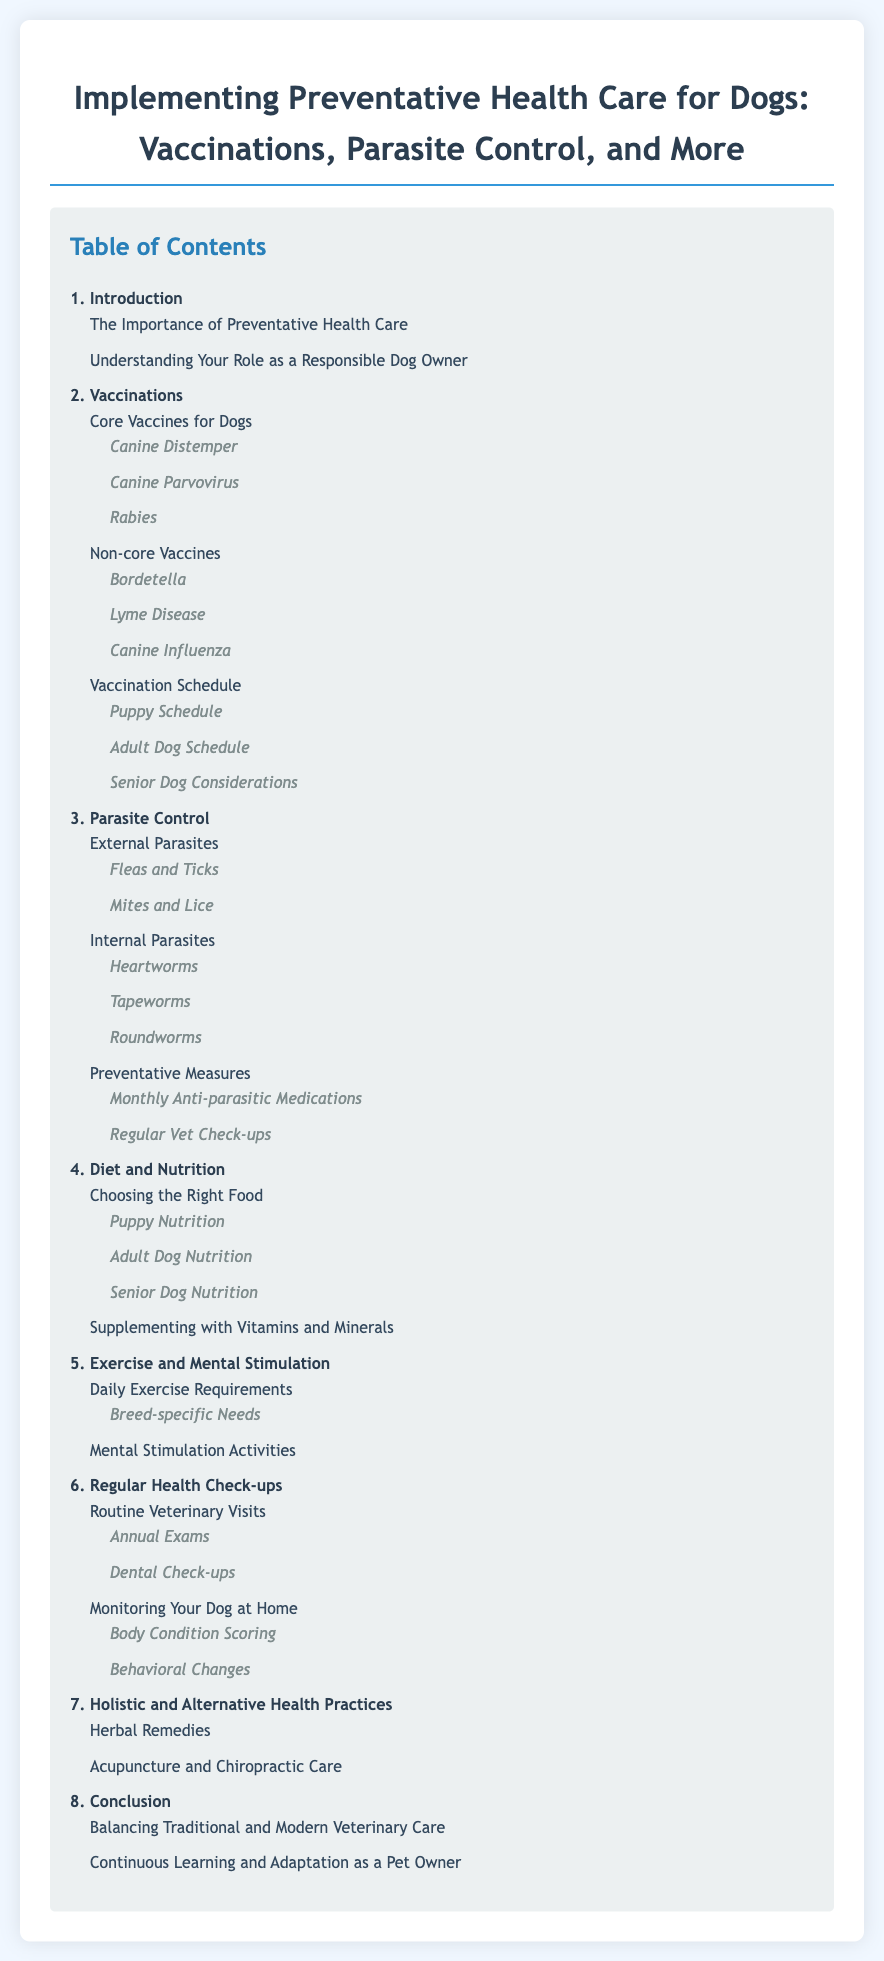what is the main title of the document? The main title is the heading at the top of the rendered document, which provides the overall subject of the content.
Answer: Implementing Preventative Health Care for Dogs: Vaccinations, Parasite Control, and More how many sections are there in the table of contents? The number of sections is determined by counting the main bullet points in the table of contents.
Answer: 8 what are core vaccines for dogs? Core vaccines are essential vaccinations recommended for all dogs to prevent serious diseases, listed in a sub-section of the vaccinations section.
Answer: Canine Distemper, Canine Parvovirus, Rabies which section covers the health check-up frequency? The section that addresses health check-ups specifies how often they should occur, which is included in the document's table of contents.
Answer: Regular Health Check-ups what is included in the preventative measures for parasites? Preventative measures refer to specific actions or treatments listed under the parasite control section to prevent parasite infestations.
Answer: Monthly Anti-parasitic Medications, Regular Vet Check-ups how many main categories are listed under parasite control? This question can be answered by counting the main sub-categories found within the parasite control section of the table of contents.
Answer: 3 what are the considerations for senior dog vaccinations? This refers to specific details about vaccination protocols tailored for older dogs, found in the vaccination schedule subsection.
Answer: Senior Dog Considerations what type of health practices are discussed beyond traditional veterinary care? The document mentions alternative health practices that complement traditional veterinary care in a specific section.
Answer: Holistic and Alternative Health Practices 